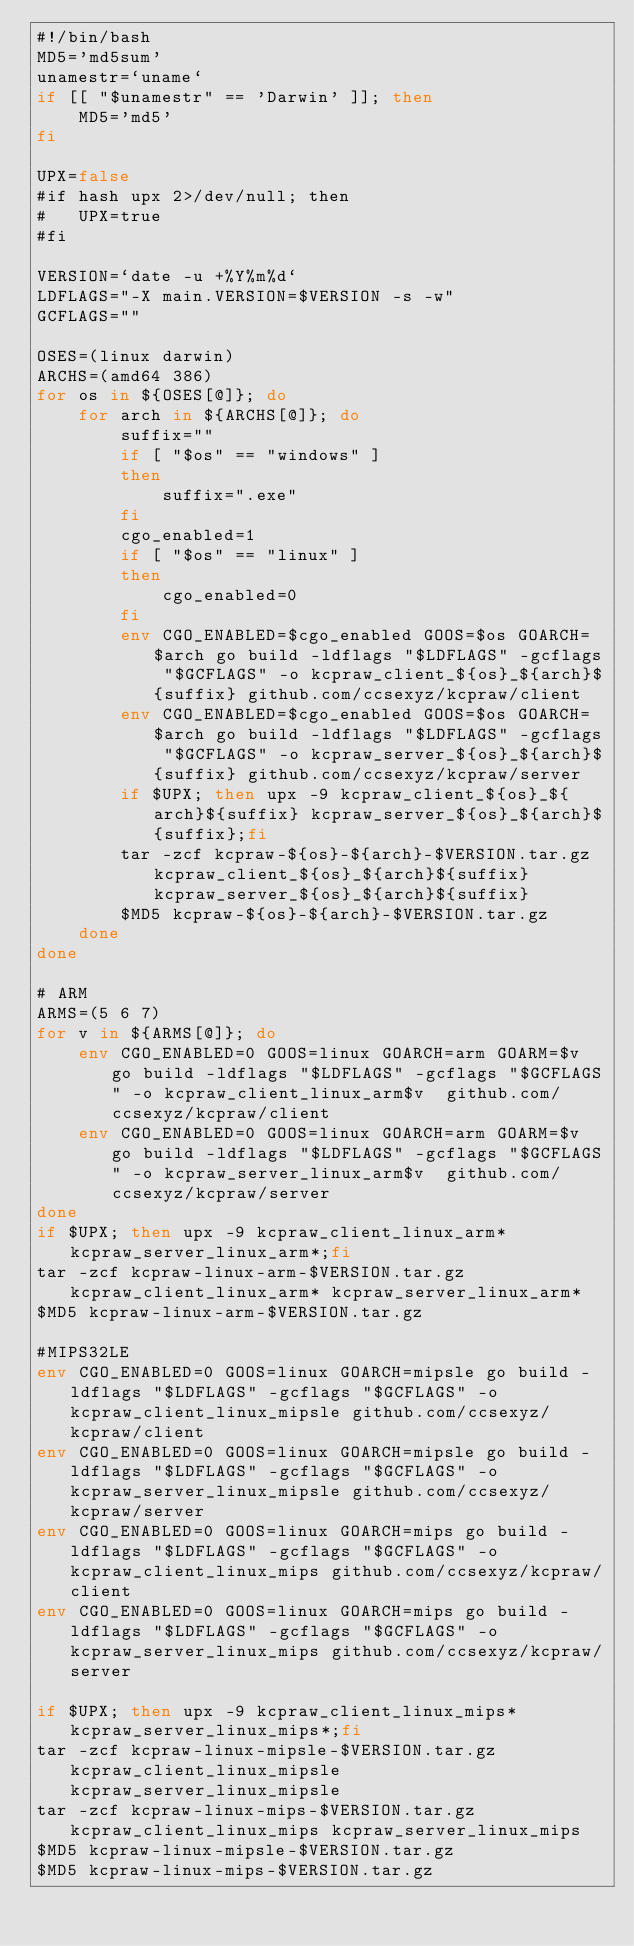Convert code to text. <code><loc_0><loc_0><loc_500><loc_500><_Bash_>#!/bin/bash
MD5='md5sum'
unamestr=`uname`
if [[ "$unamestr" == 'Darwin' ]]; then
	MD5='md5'
fi

UPX=false
#if hash upx 2>/dev/null; then
#	UPX=true
#fi

VERSION=`date -u +%Y%m%d`
LDFLAGS="-X main.VERSION=$VERSION -s -w"
GCFLAGS=""

OSES=(linux darwin)
ARCHS=(amd64 386)
for os in ${OSES[@]}; do
	for arch in ${ARCHS[@]}; do
		suffix=""
		if [ "$os" == "windows" ]
		then
			suffix=".exe"
		fi
        cgo_enabled=1
        if [ "$os" == "linux" ]
        then 
            cgo_enabled=0
        fi 
        env CGO_ENABLED=$cgo_enabled GOOS=$os GOARCH=$arch go build -ldflags "$LDFLAGS" -gcflags "$GCFLAGS" -o kcpraw_client_${os}_${arch}${suffix} github.com/ccsexyz/kcpraw/client
        env CGO_ENABLED=$cgo_enabled GOOS=$os GOARCH=$arch go build -ldflags "$LDFLAGS" -gcflags "$GCFLAGS" -o kcpraw_server_${os}_${arch}${suffix} github.com/ccsexyz/kcpraw/server
		if $UPX; then upx -9 kcpraw_client_${os}_${arch}${suffix} kcpraw_server_${os}_${arch}${suffix};fi
		tar -zcf kcpraw-${os}-${arch}-$VERSION.tar.gz kcpraw_client_${os}_${arch}${suffix} kcpraw_server_${os}_${arch}${suffix}
		$MD5 kcpraw-${os}-${arch}-$VERSION.tar.gz
	done
done

# ARM
ARMS=(5 6 7)
for v in ${ARMS[@]}; do
	env CGO_ENABLED=0 GOOS=linux GOARCH=arm GOARM=$v go build -ldflags "$LDFLAGS" -gcflags "$GCFLAGS" -o kcpraw_client_linux_arm$v  github.com/ccsexyz/kcpraw/client
	env CGO_ENABLED=0 GOOS=linux GOARCH=arm GOARM=$v go build -ldflags "$LDFLAGS" -gcflags "$GCFLAGS" -o kcpraw_server_linux_arm$v  github.com/ccsexyz/kcpraw/server
done
if $UPX; then upx -9 kcpraw_client_linux_arm* kcpraw_server_linux_arm*;fi
tar -zcf kcpraw-linux-arm-$VERSION.tar.gz kcpraw_client_linux_arm* kcpraw_server_linux_arm*
$MD5 kcpraw-linux-arm-$VERSION.tar.gz

#MIPS32LE
env CGO_ENABLED=0 GOOS=linux GOARCH=mipsle go build -ldflags "$LDFLAGS" -gcflags "$GCFLAGS" -o kcpraw_client_linux_mipsle github.com/ccsexyz/kcpraw/client
env CGO_ENABLED=0 GOOS=linux GOARCH=mipsle go build -ldflags "$LDFLAGS" -gcflags "$GCFLAGS" -o kcpraw_server_linux_mipsle github.com/ccsexyz/kcpraw/server
env CGO_ENABLED=0 GOOS=linux GOARCH=mips go build -ldflags "$LDFLAGS" -gcflags "$GCFLAGS" -o kcpraw_client_linux_mips github.com/ccsexyz/kcpraw/client
env CGO_ENABLED=0 GOOS=linux GOARCH=mips go build -ldflags "$LDFLAGS" -gcflags "$GCFLAGS" -o kcpraw_server_linux_mips github.com/ccsexyz/kcpraw/server

if $UPX; then upx -9 kcpraw_client_linux_mips* kcpraw_server_linux_mips*;fi
tar -zcf kcpraw-linux-mipsle-$VERSION.tar.gz kcpraw_client_linux_mipsle kcpraw_server_linux_mipsle
tar -zcf kcpraw-linux-mips-$VERSION.tar.gz kcpraw_client_linux_mips kcpraw_server_linux_mips
$MD5 kcpraw-linux-mipsle-$VERSION.tar.gz
$MD5 kcpraw-linux-mips-$VERSION.tar.gz
</code> 